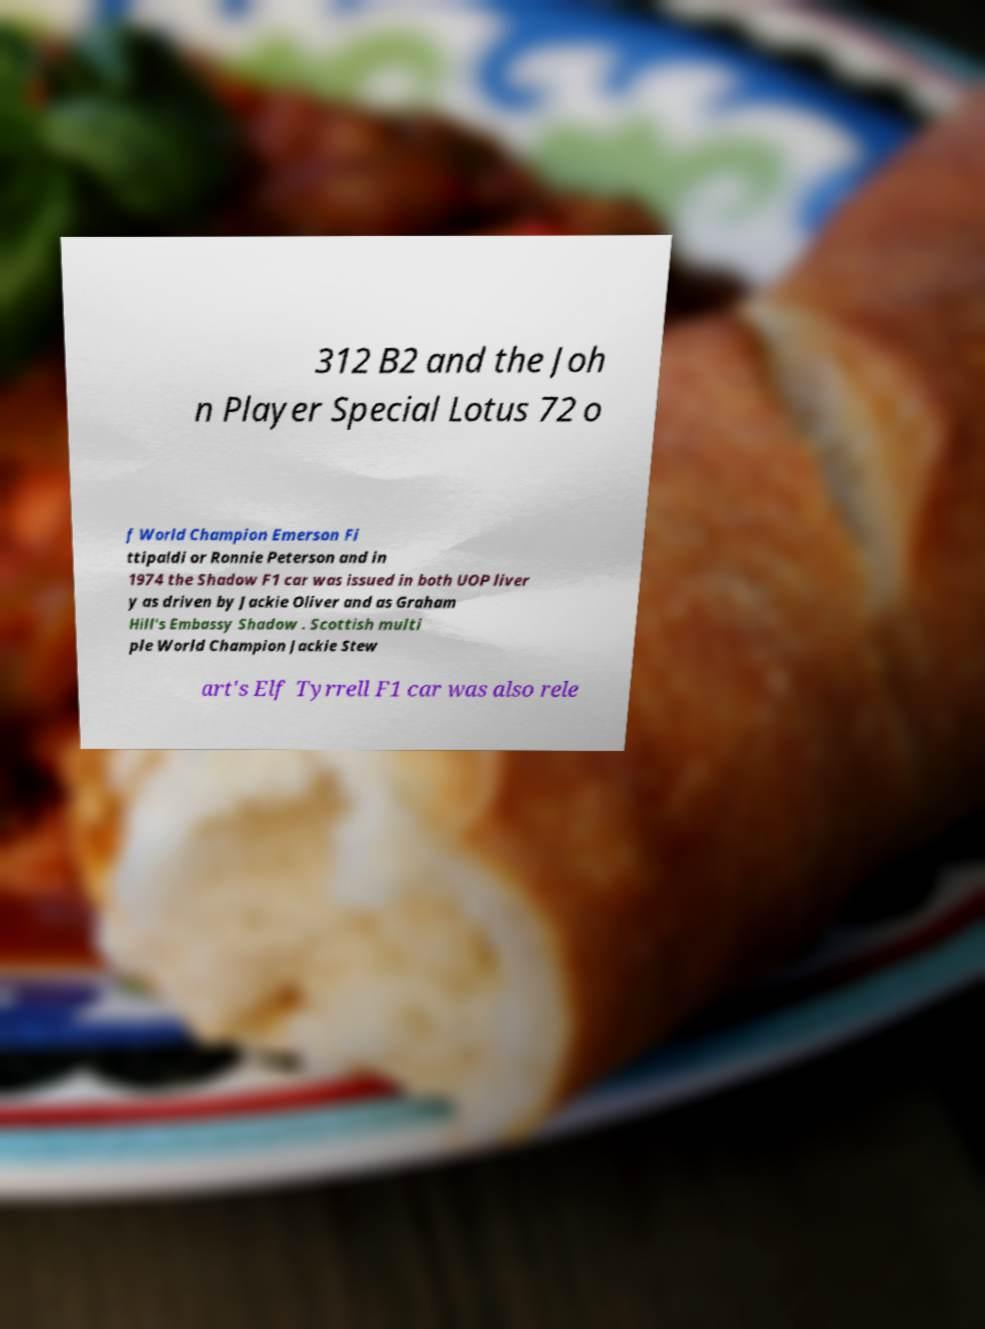There's text embedded in this image that I need extracted. Can you transcribe it verbatim? 312 B2 and the Joh n Player Special Lotus 72 o f World Champion Emerson Fi ttipaldi or Ronnie Peterson and in 1974 the Shadow F1 car was issued in both UOP liver y as driven by Jackie Oliver and as Graham Hill's Embassy Shadow . Scottish multi ple World Champion Jackie Stew art's Elf Tyrrell F1 car was also rele 